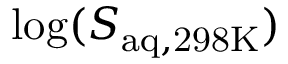<formula> <loc_0><loc_0><loc_500><loc_500>\log ( S _ { a q , 2 9 8 K } )</formula> 